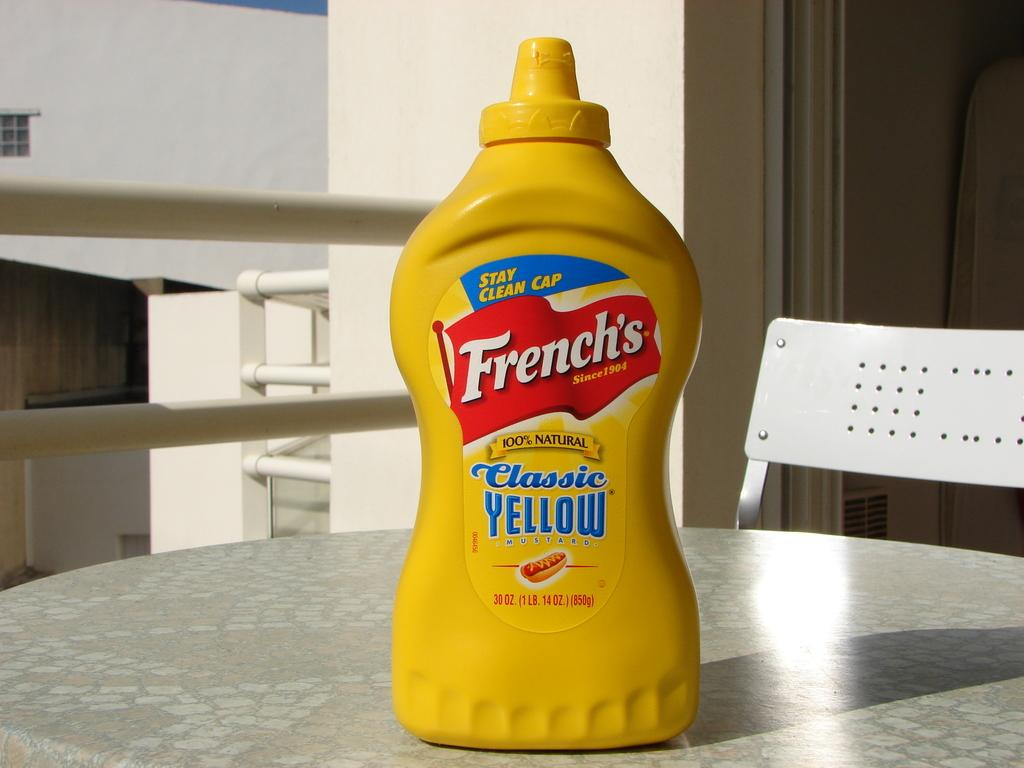Provide a one-sentence caption for the provided image. Frenches yellow mustard sitting on a table on a balcony. 